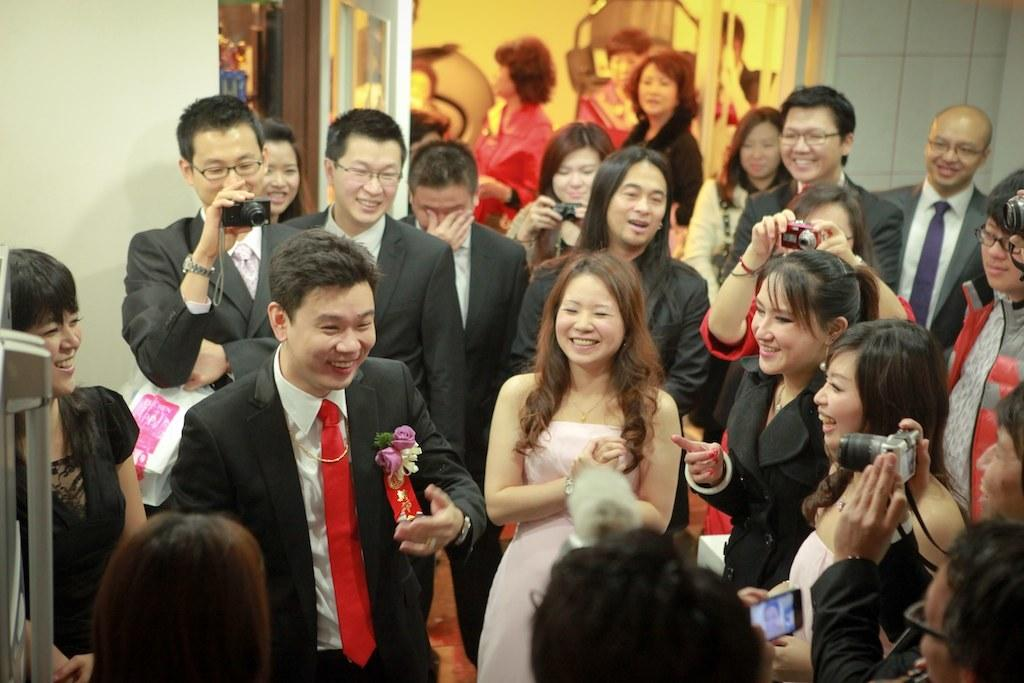What are the people in the image doing? The people in the image are standing. What objects are some of the people holding in their hands? Some people are holding cameras in their hands. Can you describe the clothing of one of the men in the image? Yes, a man in the image is wearing a red color tie around his neck. What type of authority is being exercised by the people in the image? There is no indication of any authority being exercised by the people in the image. What type of fuel is being used by the people in the image? There is no mention of any fuel being used by the people in the image. 